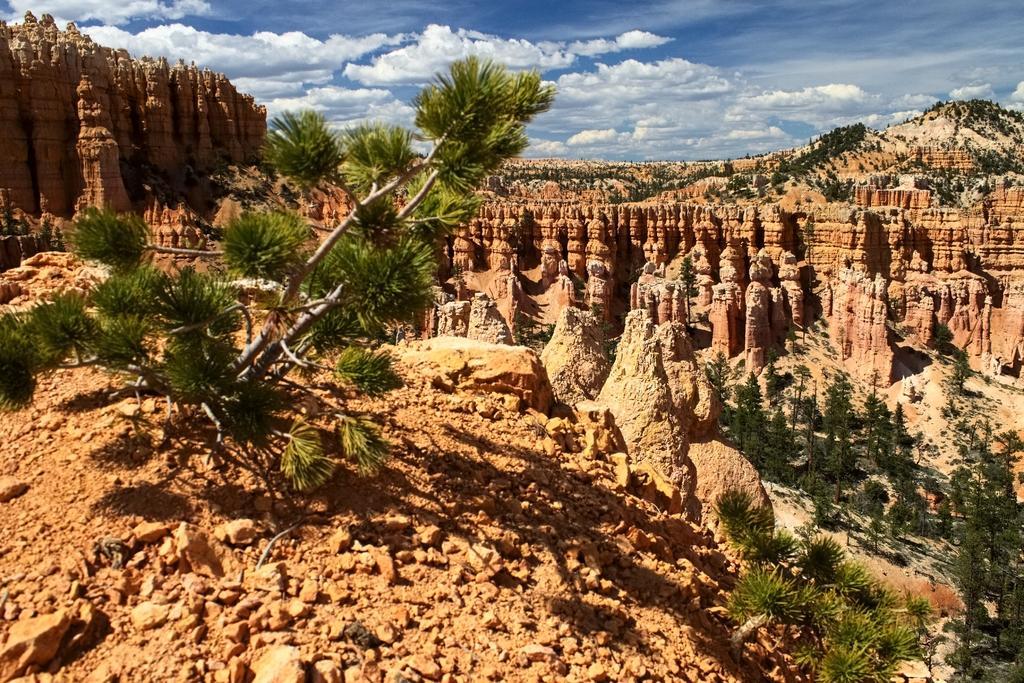Please provide a concise description of this image. In the image there are many hills and in between them there are trees. 